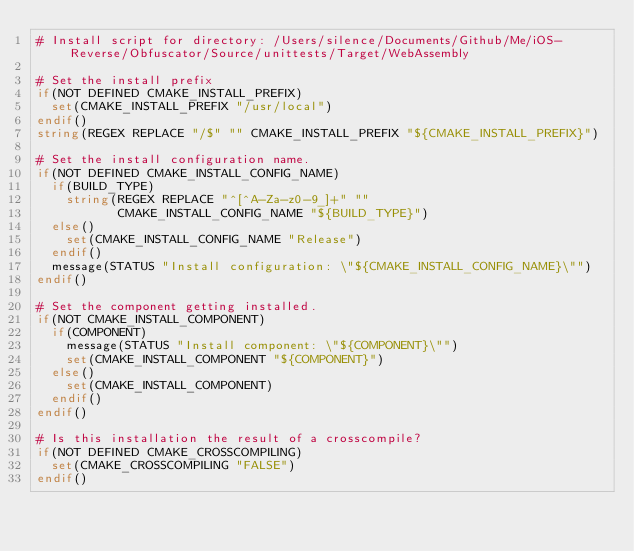<code> <loc_0><loc_0><loc_500><loc_500><_CMake_># Install script for directory: /Users/silence/Documents/Github/Me/iOS-Reverse/Obfuscator/Source/unittests/Target/WebAssembly

# Set the install prefix
if(NOT DEFINED CMAKE_INSTALL_PREFIX)
  set(CMAKE_INSTALL_PREFIX "/usr/local")
endif()
string(REGEX REPLACE "/$" "" CMAKE_INSTALL_PREFIX "${CMAKE_INSTALL_PREFIX}")

# Set the install configuration name.
if(NOT DEFINED CMAKE_INSTALL_CONFIG_NAME)
  if(BUILD_TYPE)
    string(REGEX REPLACE "^[^A-Za-z0-9_]+" ""
           CMAKE_INSTALL_CONFIG_NAME "${BUILD_TYPE}")
  else()
    set(CMAKE_INSTALL_CONFIG_NAME "Release")
  endif()
  message(STATUS "Install configuration: \"${CMAKE_INSTALL_CONFIG_NAME}\"")
endif()

# Set the component getting installed.
if(NOT CMAKE_INSTALL_COMPONENT)
  if(COMPONENT)
    message(STATUS "Install component: \"${COMPONENT}\"")
    set(CMAKE_INSTALL_COMPONENT "${COMPONENT}")
  else()
    set(CMAKE_INSTALL_COMPONENT)
  endif()
endif()

# Is this installation the result of a crosscompile?
if(NOT DEFINED CMAKE_CROSSCOMPILING)
  set(CMAKE_CROSSCOMPILING "FALSE")
endif()

</code> 